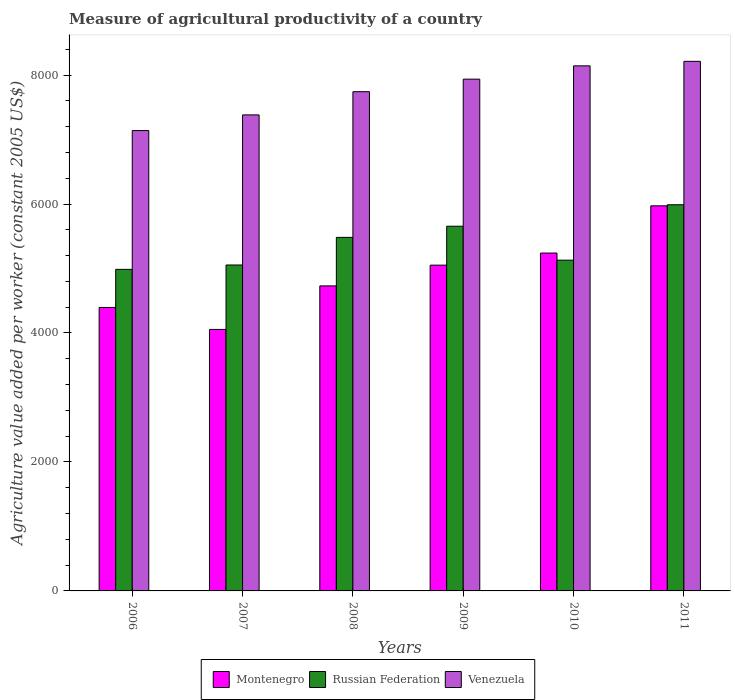How many groups of bars are there?
Your answer should be compact. 6. Are the number of bars per tick equal to the number of legend labels?
Offer a very short reply. Yes. How many bars are there on the 4th tick from the right?
Your answer should be very brief. 3. What is the label of the 3rd group of bars from the left?
Ensure brevity in your answer.  2008. What is the measure of agricultural productivity in Russian Federation in 2007?
Keep it short and to the point. 5054.21. Across all years, what is the maximum measure of agricultural productivity in Montenegro?
Give a very brief answer. 5971.47. Across all years, what is the minimum measure of agricultural productivity in Venezuela?
Keep it short and to the point. 7138.78. In which year was the measure of agricultural productivity in Venezuela minimum?
Keep it short and to the point. 2006. What is the total measure of agricultural productivity in Venezuela in the graph?
Your response must be concise. 4.66e+04. What is the difference between the measure of agricultural productivity in Russian Federation in 2007 and that in 2011?
Ensure brevity in your answer.  -934.11. What is the difference between the measure of agricultural productivity in Venezuela in 2009 and the measure of agricultural productivity in Montenegro in 2006?
Keep it short and to the point. 3540.39. What is the average measure of agricultural productivity in Russian Federation per year?
Ensure brevity in your answer.  5382.62. In the year 2011, what is the difference between the measure of agricultural productivity in Montenegro and measure of agricultural productivity in Russian Federation?
Offer a very short reply. -16.85. In how many years, is the measure of agricultural productivity in Venezuela greater than 5200 US$?
Offer a very short reply. 6. What is the ratio of the measure of agricultural productivity in Montenegro in 2007 to that in 2010?
Your response must be concise. 0.77. Is the measure of agricultural productivity in Russian Federation in 2006 less than that in 2008?
Provide a short and direct response. Yes. What is the difference between the highest and the second highest measure of agricultural productivity in Montenegro?
Keep it short and to the point. 732.05. What is the difference between the highest and the lowest measure of agricultural productivity in Russian Federation?
Provide a short and direct response. 1001.84. In how many years, is the measure of agricultural productivity in Russian Federation greater than the average measure of agricultural productivity in Russian Federation taken over all years?
Keep it short and to the point. 3. What does the 2nd bar from the left in 2011 represents?
Your answer should be very brief. Russian Federation. What does the 1st bar from the right in 2007 represents?
Your response must be concise. Venezuela. Is it the case that in every year, the sum of the measure of agricultural productivity in Russian Federation and measure of agricultural productivity in Montenegro is greater than the measure of agricultural productivity in Venezuela?
Give a very brief answer. Yes. How many bars are there?
Keep it short and to the point. 18. How many years are there in the graph?
Make the answer very short. 6. What is the difference between two consecutive major ticks on the Y-axis?
Offer a terse response. 2000. Does the graph contain any zero values?
Offer a very short reply. No. Does the graph contain grids?
Give a very brief answer. No. Where does the legend appear in the graph?
Provide a short and direct response. Bottom center. How many legend labels are there?
Provide a succinct answer. 3. How are the legend labels stacked?
Give a very brief answer. Horizontal. What is the title of the graph?
Give a very brief answer. Measure of agricultural productivity of a country. Does "Dominica" appear as one of the legend labels in the graph?
Offer a very short reply. No. What is the label or title of the Y-axis?
Offer a terse response. Agriculture value added per worker (constant 2005 US$). What is the Agriculture value added per worker (constant 2005 US$) in Montenegro in 2006?
Provide a short and direct response. 4395.77. What is the Agriculture value added per worker (constant 2005 US$) in Russian Federation in 2006?
Your answer should be compact. 4986.48. What is the Agriculture value added per worker (constant 2005 US$) of Venezuela in 2006?
Your answer should be compact. 7138.78. What is the Agriculture value added per worker (constant 2005 US$) of Montenegro in 2007?
Give a very brief answer. 4055. What is the Agriculture value added per worker (constant 2005 US$) in Russian Federation in 2007?
Keep it short and to the point. 5054.21. What is the Agriculture value added per worker (constant 2005 US$) of Venezuela in 2007?
Your answer should be compact. 7381.74. What is the Agriculture value added per worker (constant 2005 US$) in Montenegro in 2008?
Keep it short and to the point. 4730.12. What is the Agriculture value added per worker (constant 2005 US$) of Russian Federation in 2008?
Provide a short and direct response. 5482.32. What is the Agriculture value added per worker (constant 2005 US$) in Venezuela in 2008?
Ensure brevity in your answer.  7741.56. What is the Agriculture value added per worker (constant 2005 US$) in Montenegro in 2009?
Your answer should be very brief. 5051.79. What is the Agriculture value added per worker (constant 2005 US$) in Russian Federation in 2009?
Keep it short and to the point. 5655.3. What is the Agriculture value added per worker (constant 2005 US$) in Venezuela in 2009?
Your answer should be compact. 7936.15. What is the Agriculture value added per worker (constant 2005 US$) of Montenegro in 2010?
Give a very brief answer. 5239.42. What is the Agriculture value added per worker (constant 2005 US$) of Russian Federation in 2010?
Give a very brief answer. 5129.11. What is the Agriculture value added per worker (constant 2005 US$) of Venezuela in 2010?
Your response must be concise. 8142.26. What is the Agriculture value added per worker (constant 2005 US$) of Montenegro in 2011?
Make the answer very short. 5971.47. What is the Agriculture value added per worker (constant 2005 US$) in Russian Federation in 2011?
Provide a short and direct response. 5988.32. What is the Agriculture value added per worker (constant 2005 US$) in Venezuela in 2011?
Provide a short and direct response. 8212.05. Across all years, what is the maximum Agriculture value added per worker (constant 2005 US$) of Montenegro?
Make the answer very short. 5971.47. Across all years, what is the maximum Agriculture value added per worker (constant 2005 US$) in Russian Federation?
Ensure brevity in your answer.  5988.32. Across all years, what is the maximum Agriculture value added per worker (constant 2005 US$) in Venezuela?
Keep it short and to the point. 8212.05. Across all years, what is the minimum Agriculture value added per worker (constant 2005 US$) of Montenegro?
Your answer should be compact. 4055. Across all years, what is the minimum Agriculture value added per worker (constant 2005 US$) of Russian Federation?
Your answer should be very brief. 4986.48. Across all years, what is the minimum Agriculture value added per worker (constant 2005 US$) in Venezuela?
Your answer should be compact. 7138.78. What is the total Agriculture value added per worker (constant 2005 US$) in Montenegro in the graph?
Your response must be concise. 2.94e+04. What is the total Agriculture value added per worker (constant 2005 US$) in Russian Federation in the graph?
Offer a terse response. 3.23e+04. What is the total Agriculture value added per worker (constant 2005 US$) of Venezuela in the graph?
Offer a terse response. 4.66e+04. What is the difference between the Agriculture value added per worker (constant 2005 US$) in Montenegro in 2006 and that in 2007?
Ensure brevity in your answer.  340.77. What is the difference between the Agriculture value added per worker (constant 2005 US$) in Russian Federation in 2006 and that in 2007?
Keep it short and to the point. -67.73. What is the difference between the Agriculture value added per worker (constant 2005 US$) in Venezuela in 2006 and that in 2007?
Make the answer very short. -242.97. What is the difference between the Agriculture value added per worker (constant 2005 US$) of Montenegro in 2006 and that in 2008?
Make the answer very short. -334.36. What is the difference between the Agriculture value added per worker (constant 2005 US$) of Russian Federation in 2006 and that in 2008?
Your response must be concise. -495.85. What is the difference between the Agriculture value added per worker (constant 2005 US$) in Venezuela in 2006 and that in 2008?
Keep it short and to the point. -602.78. What is the difference between the Agriculture value added per worker (constant 2005 US$) of Montenegro in 2006 and that in 2009?
Your answer should be very brief. -656.03. What is the difference between the Agriculture value added per worker (constant 2005 US$) in Russian Federation in 2006 and that in 2009?
Make the answer very short. -668.83. What is the difference between the Agriculture value added per worker (constant 2005 US$) in Venezuela in 2006 and that in 2009?
Your response must be concise. -797.38. What is the difference between the Agriculture value added per worker (constant 2005 US$) in Montenegro in 2006 and that in 2010?
Offer a terse response. -843.65. What is the difference between the Agriculture value added per worker (constant 2005 US$) in Russian Federation in 2006 and that in 2010?
Provide a short and direct response. -142.63. What is the difference between the Agriculture value added per worker (constant 2005 US$) in Venezuela in 2006 and that in 2010?
Offer a very short reply. -1003.49. What is the difference between the Agriculture value added per worker (constant 2005 US$) of Montenegro in 2006 and that in 2011?
Keep it short and to the point. -1575.7. What is the difference between the Agriculture value added per worker (constant 2005 US$) of Russian Federation in 2006 and that in 2011?
Provide a succinct answer. -1001.84. What is the difference between the Agriculture value added per worker (constant 2005 US$) in Venezuela in 2006 and that in 2011?
Keep it short and to the point. -1073.27. What is the difference between the Agriculture value added per worker (constant 2005 US$) in Montenegro in 2007 and that in 2008?
Keep it short and to the point. -675.13. What is the difference between the Agriculture value added per worker (constant 2005 US$) of Russian Federation in 2007 and that in 2008?
Provide a succinct answer. -428.11. What is the difference between the Agriculture value added per worker (constant 2005 US$) of Venezuela in 2007 and that in 2008?
Provide a succinct answer. -359.82. What is the difference between the Agriculture value added per worker (constant 2005 US$) of Montenegro in 2007 and that in 2009?
Make the answer very short. -996.8. What is the difference between the Agriculture value added per worker (constant 2005 US$) of Russian Federation in 2007 and that in 2009?
Ensure brevity in your answer.  -601.1. What is the difference between the Agriculture value added per worker (constant 2005 US$) in Venezuela in 2007 and that in 2009?
Your answer should be compact. -554.41. What is the difference between the Agriculture value added per worker (constant 2005 US$) in Montenegro in 2007 and that in 2010?
Keep it short and to the point. -1184.42. What is the difference between the Agriculture value added per worker (constant 2005 US$) in Russian Federation in 2007 and that in 2010?
Your response must be concise. -74.9. What is the difference between the Agriculture value added per worker (constant 2005 US$) of Venezuela in 2007 and that in 2010?
Offer a very short reply. -760.52. What is the difference between the Agriculture value added per worker (constant 2005 US$) of Montenegro in 2007 and that in 2011?
Your answer should be very brief. -1916.47. What is the difference between the Agriculture value added per worker (constant 2005 US$) of Russian Federation in 2007 and that in 2011?
Ensure brevity in your answer.  -934.11. What is the difference between the Agriculture value added per worker (constant 2005 US$) of Venezuela in 2007 and that in 2011?
Your response must be concise. -830.31. What is the difference between the Agriculture value added per worker (constant 2005 US$) in Montenegro in 2008 and that in 2009?
Ensure brevity in your answer.  -321.67. What is the difference between the Agriculture value added per worker (constant 2005 US$) in Russian Federation in 2008 and that in 2009?
Keep it short and to the point. -172.98. What is the difference between the Agriculture value added per worker (constant 2005 US$) in Venezuela in 2008 and that in 2009?
Provide a short and direct response. -194.59. What is the difference between the Agriculture value added per worker (constant 2005 US$) in Montenegro in 2008 and that in 2010?
Give a very brief answer. -509.3. What is the difference between the Agriculture value added per worker (constant 2005 US$) in Russian Federation in 2008 and that in 2010?
Provide a succinct answer. 353.21. What is the difference between the Agriculture value added per worker (constant 2005 US$) of Venezuela in 2008 and that in 2010?
Your answer should be very brief. -400.7. What is the difference between the Agriculture value added per worker (constant 2005 US$) in Montenegro in 2008 and that in 2011?
Offer a very short reply. -1241.34. What is the difference between the Agriculture value added per worker (constant 2005 US$) in Russian Federation in 2008 and that in 2011?
Make the answer very short. -506. What is the difference between the Agriculture value added per worker (constant 2005 US$) of Venezuela in 2008 and that in 2011?
Keep it short and to the point. -470.49. What is the difference between the Agriculture value added per worker (constant 2005 US$) of Montenegro in 2009 and that in 2010?
Provide a short and direct response. -187.63. What is the difference between the Agriculture value added per worker (constant 2005 US$) of Russian Federation in 2009 and that in 2010?
Your answer should be very brief. 526.19. What is the difference between the Agriculture value added per worker (constant 2005 US$) in Venezuela in 2009 and that in 2010?
Give a very brief answer. -206.11. What is the difference between the Agriculture value added per worker (constant 2005 US$) in Montenegro in 2009 and that in 2011?
Offer a very short reply. -919.67. What is the difference between the Agriculture value added per worker (constant 2005 US$) in Russian Federation in 2009 and that in 2011?
Your answer should be compact. -333.01. What is the difference between the Agriculture value added per worker (constant 2005 US$) in Venezuela in 2009 and that in 2011?
Give a very brief answer. -275.89. What is the difference between the Agriculture value added per worker (constant 2005 US$) of Montenegro in 2010 and that in 2011?
Your answer should be compact. -732.05. What is the difference between the Agriculture value added per worker (constant 2005 US$) of Russian Federation in 2010 and that in 2011?
Make the answer very short. -859.21. What is the difference between the Agriculture value added per worker (constant 2005 US$) of Venezuela in 2010 and that in 2011?
Your response must be concise. -69.79. What is the difference between the Agriculture value added per worker (constant 2005 US$) in Montenegro in 2006 and the Agriculture value added per worker (constant 2005 US$) in Russian Federation in 2007?
Offer a terse response. -658.44. What is the difference between the Agriculture value added per worker (constant 2005 US$) of Montenegro in 2006 and the Agriculture value added per worker (constant 2005 US$) of Venezuela in 2007?
Your answer should be very brief. -2985.98. What is the difference between the Agriculture value added per worker (constant 2005 US$) in Russian Federation in 2006 and the Agriculture value added per worker (constant 2005 US$) in Venezuela in 2007?
Keep it short and to the point. -2395.27. What is the difference between the Agriculture value added per worker (constant 2005 US$) in Montenegro in 2006 and the Agriculture value added per worker (constant 2005 US$) in Russian Federation in 2008?
Keep it short and to the point. -1086.55. What is the difference between the Agriculture value added per worker (constant 2005 US$) in Montenegro in 2006 and the Agriculture value added per worker (constant 2005 US$) in Venezuela in 2008?
Your answer should be very brief. -3345.79. What is the difference between the Agriculture value added per worker (constant 2005 US$) in Russian Federation in 2006 and the Agriculture value added per worker (constant 2005 US$) in Venezuela in 2008?
Give a very brief answer. -2755.08. What is the difference between the Agriculture value added per worker (constant 2005 US$) in Montenegro in 2006 and the Agriculture value added per worker (constant 2005 US$) in Russian Federation in 2009?
Make the answer very short. -1259.54. What is the difference between the Agriculture value added per worker (constant 2005 US$) of Montenegro in 2006 and the Agriculture value added per worker (constant 2005 US$) of Venezuela in 2009?
Make the answer very short. -3540.39. What is the difference between the Agriculture value added per worker (constant 2005 US$) in Russian Federation in 2006 and the Agriculture value added per worker (constant 2005 US$) in Venezuela in 2009?
Ensure brevity in your answer.  -2949.68. What is the difference between the Agriculture value added per worker (constant 2005 US$) in Montenegro in 2006 and the Agriculture value added per worker (constant 2005 US$) in Russian Federation in 2010?
Your answer should be very brief. -733.34. What is the difference between the Agriculture value added per worker (constant 2005 US$) of Montenegro in 2006 and the Agriculture value added per worker (constant 2005 US$) of Venezuela in 2010?
Offer a very short reply. -3746.5. What is the difference between the Agriculture value added per worker (constant 2005 US$) of Russian Federation in 2006 and the Agriculture value added per worker (constant 2005 US$) of Venezuela in 2010?
Offer a terse response. -3155.79. What is the difference between the Agriculture value added per worker (constant 2005 US$) of Montenegro in 2006 and the Agriculture value added per worker (constant 2005 US$) of Russian Federation in 2011?
Your answer should be compact. -1592.55. What is the difference between the Agriculture value added per worker (constant 2005 US$) of Montenegro in 2006 and the Agriculture value added per worker (constant 2005 US$) of Venezuela in 2011?
Provide a short and direct response. -3816.28. What is the difference between the Agriculture value added per worker (constant 2005 US$) in Russian Federation in 2006 and the Agriculture value added per worker (constant 2005 US$) in Venezuela in 2011?
Keep it short and to the point. -3225.57. What is the difference between the Agriculture value added per worker (constant 2005 US$) of Montenegro in 2007 and the Agriculture value added per worker (constant 2005 US$) of Russian Federation in 2008?
Your answer should be compact. -1427.33. What is the difference between the Agriculture value added per worker (constant 2005 US$) of Montenegro in 2007 and the Agriculture value added per worker (constant 2005 US$) of Venezuela in 2008?
Give a very brief answer. -3686.56. What is the difference between the Agriculture value added per worker (constant 2005 US$) in Russian Federation in 2007 and the Agriculture value added per worker (constant 2005 US$) in Venezuela in 2008?
Your answer should be compact. -2687.35. What is the difference between the Agriculture value added per worker (constant 2005 US$) in Montenegro in 2007 and the Agriculture value added per worker (constant 2005 US$) in Russian Federation in 2009?
Offer a terse response. -1600.31. What is the difference between the Agriculture value added per worker (constant 2005 US$) of Montenegro in 2007 and the Agriculture value added per worker (constant 2005 US$) of Venezuela in 2009?
Ensure brevity in your answer.  -3881.16. What is the difference between the Agriculture value added per worker (constant 2005 US$) of Russian Federation in 2007 and the Agriculture value added per worker (constant 2005 US$) of Venezuela in 2009?
Offer a terse response. -2881.95. What is the difference between the Agriculture value added per worker (constant 2005 US$) in Montenegro in 2007 and the Agriculture value added per worker (constant 2005 US$) in Russian Federation in 2010?
Offer a terse response. -1074.11. What is the difference between the Agriculture value added per worker (constant 2005 US$) in Montenegro in 2007 and the Agriculture value added per worker (constant 2005 US$) in Venezuela in 2010?
Your answer should be compact. -4087.27. What is the difference between the Agriculture value added per worker (constant 2005 US$) of Russian Federation in 2007 and the Agriculture value added per worker (constant 2005 US$) of Venezuela in 2010?
Offer a very short reply. -3088.06. What is the difference between the Agriculture value added per worker (constant 2005 US$) of Montenegro in 2007 and the Agriculture value added per worker (constant 2005 US$) of Russian Federation in 2011?
Ensure brevity in your answer.  -1933.32. What is the difference between the Agriculture value added per worker (constant 2005 US$) in Montenegro in 2007 and the Agriculture value added per worker (constant 2005 US$) in Venezuela in 2011?
Give a very brief answer. -4157.05. What is the difference between the Agriculture value added per worker (constant 2005 US$) of Russian Federation in 2007 and the Agriculture value added per worker (constant 2005 US$) of Venezuela in 2011?
Your answer should be compact. -3157.84. What is the difference between the Agriculture value added per worker (constant 2005 US$) of Montenegro in 2008 and the Agriculture value added per worker (constant 2005 US$) of Russian Federation in 2009?
Your answer should be very brief. -925.18. What is the difference between the Agriculture value added per worker (constant 2005 US$) in Montenegro in 2008 and the Agriculture value added per worker (constant 2005 US$) in Venezuela in 2009?
Give a very brief answer. -3206.03. What is the difference between the Agriculture value added per worker (constant 2005 US$) in Russian Federation in 2008 and the Agriculture value added per worker (constant 2005 US$) in Venezuela in 2009?
Give a very brief answer. -2453.83. What is the difference between the Agriculture value added per worker (constant 2005 US$) of Montenegro in 2008 and the Agriculture value added per worker (constant 2005 US$) of Russian Federation in 2010?
Offer a terse response. -398.99. What is the difference between the Agriculture value added per worker (constant 2005 US$) in Montenegro in 2008 and the Agriculture value added per worker (constant 2005 US$) in Venezuela in 2010?
Offer a terse response. -3412.14. What is the difference between the Agriculture value added per worker (constant 2005 US$) in Russian Federation in 2008 and the Agriculture value added per worker (constant 2005 US$) in Venezuela in 2010?
Your response must be concise. -2659.94. What is the difference between the Agriculture value added per worker (constant 2005 US$) of Montenegro in 2008 and the Agriculture value added per worker (constant 2005 US$) of Russian Federation in 2011?
Offer a very short reply. -1258.19. What is the difference between the Agriculture value added per worker (constant 2005 US$) of Montenegro in 2008 and the Agriculture value added per worker (constant 2005 US$) of Venezuela in 2011?
Your answer should be very brief. -3481.93. What is the difference between the Agriculture value added per worker (constant 2005 US$) in Russian Federation in 2008 and the Agriculture value added per worker (constant 2005 US$) in Venezuela in 2011?
Your answer should be very brief. -2729.73. What is the difference between the Agriculture value added per worker (constant 2005 US$) in Montenegro in 2009 and the Agriculture value added per worker (constant 2005 US$) in Russian Federation in 2010?
Make the answer very short. -77.32. What is the difference between the Agriculture value added per worker (constant 2005 US$) in Montenegro in 2009 and the Agriculture value added per worker (constant 2005 US$) in Venezuela in 2010?
Make the answer very short. -3090.47. What is the difference between the Agriculture value added per worker (constant 2005 US$) of Russian Federation in 2009 and the Agriculture value added per worker (constant 2005 US$) of Venezuela in 2010?
Provide a succinct answer. -2486.96. What is the difference between the Agriculture value added per worker (constant 2005 US$) in Montenegro in 2009 and the Agriculture value added per worker (constant 2005 US$) in Russian Federation in 2011?
Offer a very short reply. -936.52. What is the difference between the Agriculture value added per worker (constant 2005 US$) in Montenegro in 2009 and the Agriculture value added per worker (constant 2005 US$) in Venezuela in 2011?
Give a very brief answer. -3160.26. What is the difference between the Agriculture value added per worker (constant 2005 US$) in Russian Federation in 2009 and the Agriculture value added per worker (constant 2005 US$) in Venezuela in 2011?
Keep it short and to the point. -2556.75. What is the difference between the Agriculture value added per worker (constant 2005 US$) in Montenegro in 2010 and the Agriculture value added per worker (constant 2005 US$) in Russian Federation in 2011?
Keep it short and to the point. -748.9. What is the difference between the Agriculture value added per worker (constant 2005 US$) in Montenegro in 2010 and the Agriculture value added per worker (constant 2005 US$) in Venezuela in 2011?
Your answer should be compact. -2972.63. What is the difference between the Agriculture value added per worker (constant 2005 US$) of Russian Federation in 2010 and the Agriculture value added per worker (constant 2005 US$) of Venezuela in 2011?
Give a very brief answer. -3082.94. What is the average Agriculture value added per worker (constant 2005 US$) of Montenegro per year?
Make the answer very short. 4907.26. What is the average Agriculture value added per worker (constant 2005 US$) in Russian Federation per year?
Ensure brevity in your answer.  5382.62. What is the average Agriculture value added per worker (constant 2005 US$) in Venezuela per year?
Provide a short and direct response. 7758.76. In the year 2006, what is the difference between the Agriculture value added per worker (constant 2005 US$) in Montenegro and Agriculture value added per worker (constant 2005 US$) in Russian Federation?
Offer a terse response. -590.71. In the year 2006, what is the difference between the Agriculture value added per worker (constant 2005 US$) in Montenegro and Agriculture value added per worker (constant 2005 US$) in Venezuela?
Give a very brief answer. -2743.01. In the year 2006, what is the difference between the Agriculture value added per worker (constant 2005 US$) in Russian Federation and Agriculture value added per worker (constant 2005 US$) in Venezuela?
Offer a terse response. -2152.3. In the year 2007, what is the difference between the Agriculture value added per worker (constant 2005 US$) in Montenegro and Agriculture value added per worker (constant 2005 US$) in Russian Federation?
Provide a succinct answer. -999.21. In the year 2007, what is the difference between the Agriculture value added per worker (constant 2005 US$) in Montenegro and Agriculture value added per worker (constant 2005 US$) in Venezuela?
Offer a very short reply. -3326.75. In the year 2007, what is the difference between the Agriculture value added per worker (constant 2005 US$) of Russian Federation and Agriculture value added per worker (constant 2005 US$) of Venezuela?
Give a very brief answer. -2327.54. In the year 2008, what is the difference between the Agriculture value added per worker (constant 2005 US$) in Montenegro and Agriculture value added per worker (constant 2005 US$) in Russian Federation?
Keep it short and to the point. -752.2. In the year 2008, what is the difference between the Agriculture value added per worker (constant 2005 US$) of Montenegro and Agriculture value added per worker (constant 2005 US$) of Venezuela?
Your response must be concise. -3011.44. In the year 2008, what is the difference between the Agriculture value added per worker (constant 2005 US$) of Russian Federation and Agriculture value added per worker (constant 2005 US$) of Venezuela?
Make the answer very short. -2259.24. In the year 2009, what is the difference between the Agriculture value added per worker (constant 2005 US$) in Montenegro and Agriculture value added per worker (constant 2005 US$) in Russian Federation?
Your response must be concise. -603.51. In the year 2009, what is the difference between the Agriculture value added per worker (constant 2005 US$) in Montenegro and Agriculture value added per worker (constant 2005 US$) in Venezuela?
Offer a terse response. -2884.36. In the year 2009, what is the difference between the Agriculture value added per worker (constant 2005 US$) in Russian Federation and Agriculture value added per worker (constant 2005 US$) in Venezuela?
Give a very brief answer. -2280.85. In the year 2010, what is the difference between the Agriculture value added per worker (constant 2005 US$) in Montenegro and Agriculture value added per worker (constant 2005 US$) in Russian Federation?
Make the answer very short. 110.31. In the year 2010, what is the difference between the Agriculture value added per worker (constant 2005 US$) of Montenegro and Agriculture value added per worker (constant 2005 US$) of Venezuela?
Provide a short and direct response. -2902.84. In the year 2010, what is the difference between the Agriculture value added per worker (constant 2005 US$) of Russian Federation and Agriculture value added per worker (constant 2005 US$) of Venezuela?
Offer a very short reply. -3013.15. In the year 2011, what is the difference between the Agriculture value added per worker (constant 2005 US$) of Montenegro and Agriculture value added per worker (constant 2005 US$) of Russian Federation?
Give a very brief answer. -16.85. In the year 2011, what is the difference between the Agriculture value added per worker (constant 2005 US$) in Montenegro and Agriculture value added per worker (constant 2005 US$) in Venezuela?
Keep it short and to the point. -2240.58. In the year 2011, what is the difference between the Agriculture value added per worker (constant 2005 US$) of Russian Federation and Agriculture value added per worker (constant 2005 US$) of Venezuela?
Offer a terse response. -2223.73. What is the ratio of the Agriculture value added per worker (constant 2005 US$) in Montenegro in 2006 to that in 2007?
Your answer should be compact. 1.08. What is the ratio of the Agriculture value added per worker (constant 2005 US$) of Russian Federation in 2006 to that in 2007?
Make the answer very short. 0.99. What is the ratio of the Agriculture value added per worker (constant 2005 US$) of Venezuela in 2006 to that in 2007?
Keep it short and to the point. 0.97. What is the ratio of the Agriculture value added per worker (constant 2005 US$) of Montenegro in 2006 to that in 2008?
Offer a terse response. 0.93. What is the ratio of the Agriculture value added per worker (constant 2005 US$) of Russian Federation in 2006 to that in 2008?
Offer a very short reply. 0.91. What is the ratio of the Agriculture value added per worker (constant 2005 US$) in Venezuela in 2006 to that in 2008?
Your response must be concise. 0.92. What is the ratio of the Agriculture value added per worker (constant 2005 US$) of Montenegro in 2006 to that in 2009?
Provide a short and direct response. 0.87. What is the ratio of the Agriculture value added per worker (constant 2005 US$) of Russian Federation in 2006 to that in 2009?
Give a very brief answer. 0.88. What is the ratio of the Agriculture value added per worker (constant 2005 US$) in Venezuela in 2006 to that in 2009?
Keep it short and to the point. 0.9. What is the ratio of the Agriculture value added per worker (constant 2005 US$) of Montenegro in 2006 to that in 2010?
Give a very brief answer. 0.84. What is the ratio of the Agriculture value added per worker (constant 2005 US$) in Russian Federation in 2006 to that in 2010?
Ensure brevity in your answer.  0.97. What is the ratio of the Agriculture value added per worker (constant 2005 US$) in Venezuela in 2006 to that in 2010?
Provide a short and direct response. 0.88. What is the ratio of the Agriculture value added per worker (constant 2005 US$) of Montenegro in 2006 to that in 2011?
Provide a short and direct response. 0.74. What is the ratio of the Agriculture value added per worker (constant 2005 US$) of Russian Federation in 2006 to that in 2011?
Your answer should be compact. 0.83. What is the ratio of the Agriculture value added per worker (constant 2005 US$) of Venezuela in 2006 to that in 2011?
Make the answer very short. 0.87. What is the ratio of the Agriculture value added per worker (constant 2005 US$) of Montenegro in 2007 to that in 2008?
Your answer should be compact. 0.86. What is the ratio of the Agriculture value added per worker (constant 2005 US$) in Russian Federation in 2007 to that in 2008?
Keep it short and to the point. 0.92. What is the ratio of the Agriculture value added per worker (constant 2005 US$) of Venezuela in 2007 to that in 2008?
Offer a terse response. 0.95. What is the ratio of the Agriculture value added per worker (constant 2005 US$) in Montenegro in 2007 to that in 2009?
Your answer should be very brief. 0.8. What is the ratio of the Agriculture value added per worker (constant 2005 US$) in Russian Federation in 2007 to that in 2009?
Ensure brevity in your answer.  0.89. What is the ratio of the Agriculture value added per worker (constant 2005 US$) of Venezuela in 2007 to that in 2009?
Ensure brevity in your answer.  0.93. What is the ratio of the Agriculture value added per worker (constant 2005 US$) in Montenegro in 2007 to that in 2010?
Provide a succinct answer. 0.77. What is the ratio of the Agriculture value added per worker (constant 2005 US$) in Russian Federation in 2007 to that in 2010?
Offer a terse response. 0.99. What is the ratio of the Agriculture value added per worker (constant 2005 US$) of Venezuela in 2007 to that in 2010?
Ensure brevity in your answer.  0.91. What is the ratio of the Agriculture value added per worker (constant 2005 US$) in Montenegro in 2007 to that in 2011?
Your answer should be very brief. 0.68. What is the ratio of the Agriculture value added per worker (constant 2005 US$) of Russian Federation in 2007 to that in 2011?
Offer a terse response. 0.84. What is the ratio of the Agriculture value added per worker (constant 2005 US$) in Venezuela in 2007 to that in 2011?
Your response must be concise. 0.9. What is the ratio of the Agriculture value added per worker (constant 2005 US$) in Montenegro in 2008 to that in 2009?
Give a very brief answer. 0.94. What is the ratio of the Agriculture value added per worker (constant 2005 US$) in Russian Federation in 2008 to that in 2009?
Your answer should be very brief. 0.97. What is the ratio of the Agriculture value added per worker (constant 2005 US$) in Venezuela in 2008 to that in 2009?
Your answer should be compact. 0.98. What is the ratio of the Agriculture value added per worker (constant 2005 US$) of Montenegro in 2008 to that in 2010?
Provide a short and direct response. 0.9. What is the ratio of the Agriculture value added per worker (constant 2005 US$) of Russian Federation in 2008 to that in 2010?
Provide a succinct answer. 1.07. What is the ratio of the Agriculture value added per worker (constant 2005 US$) in Venezuela in 2008 to that in 2010?
Your response must be concise. 0.95. What is the ratio of the Agriculture value added per worker (constant 2005 US$) in Montenegro in 2008 to that in 2011?
Give a very brief answer. 0.79. What is the ratio of the Agriculture value added per worker (constant 2005 US$) of Russian Federation in 2008 to that in 2011?
Keep it short and to the point. 0.92. What is the ratio of the Agriculture value added per worker (constant 2005 US$) of Venezuela in 2008 to that in 2011?
Provide a short and direct response. 0.94. What is the ratio of the Agriculture value added per worker (constant 2005 US$) in Montenegro in 2009 to that in 2010?
Make the answer very short. 0.96. What is the ratio of the Agriculture value added per worker (constant 2005 US$) of Russian Federation in 2009 to that in 2010?
Give a very brief answer. 1.1. What is the ratio of the Agriculture value added per worker (constant 2005 US$) of Venezuela in 2009 to that in 2010?
Make the answer very short. 0.97. What is the ratio of the Agriculture value added per worker (constant 2005 US$) of Montenegro in 2009 to that in 2011?
Provide a succinct answer. 0.85. What is the ratio of the Agriculture value added per worker (constant 2005 US$) of Russian Federation in 2009 to that in 2011?
Offer a terse response. 0.94. What is the ratio of the Agriculture value added per worker (constant 2005 US$) of Venezuela in 2009 to that in 2011?
Give a very brief answer. 0.97. What is the ratio of the Agriculture value added per worker (constant 2005 US$) in Montenegro in 2010 to that in 2011?
Your response must be concise. 0.88. What is the ratio of the Agriculture value added per worker (constant 2005 US$) of Russian Federation in 2010 to that in 2011?
Keep it short and to the point. 0.86. What is the ratio of the Agriculture value added per worker (constant 2005 US$) of Venezuela in 2010 to that in 2011?
Make the answer very short. 0.99. What is the difference between the highest and the second highest Agriculture value added per worker (constant 2005 US$) in Montenegro?
Offer a terse response. 732.05. What is the difference between the highest and the second highest Agriculture value added per worker (constant 2005 US$) of Russian Federation?
Offer a very short reply. 333.01. What is the difference between the highest and the second highest Agriculture value added per worker (constant 2005 US$) of Venezuela?
Ensure brevity in your answer.  69.79. What is the difference between the highest and the lowest Agriculture value added per worker (constant 2005 US$) of Montenegro?
Ensure brevity in your answer.  1916.47. What is the difference between the highest and the lowest Agriculture value added per worker (constant 2005 US$) of Russian Federation?
Your answer should be very brief. 1001.84. What is the difference between the highest and the lowest Agriculture value added per worker (constant 2005 US$) in Venezuela?
Offer a very short reply. 1073.27. 